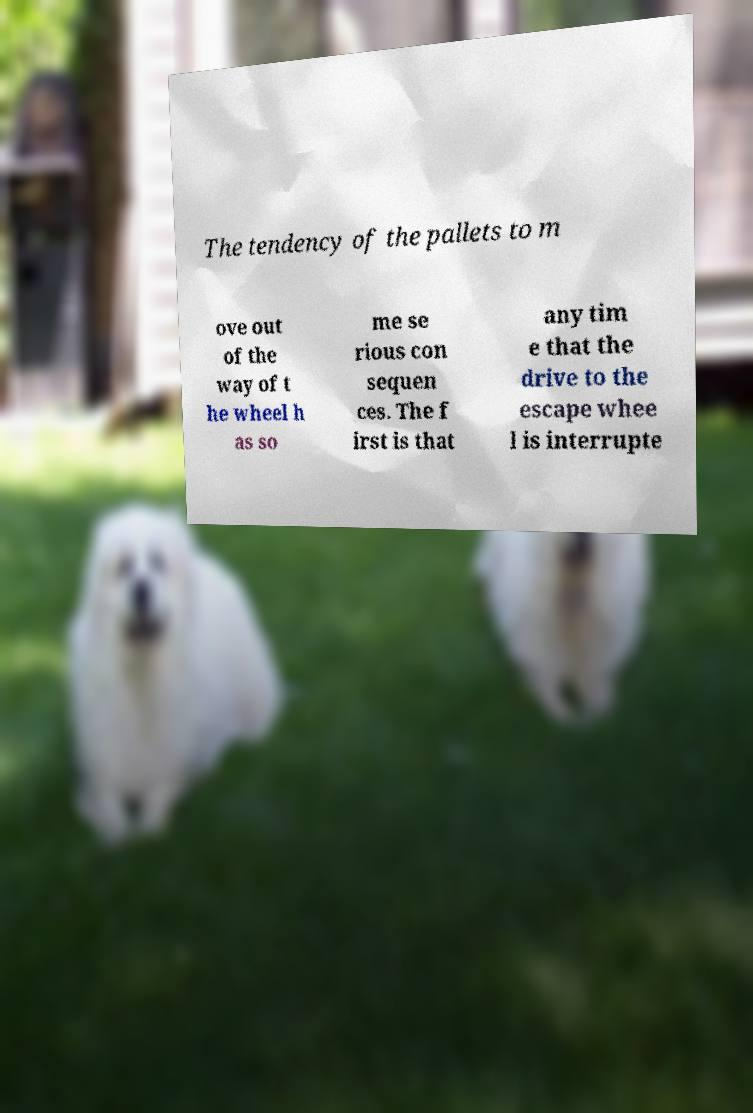Can you accurately transcribe the text from the provided image for me? The tendency of the pallets to m ove out of the way of t he wheel h as so me se rious con sequen ces. The f irst is that any tim e that the drive to the escape whee l is interrupte 